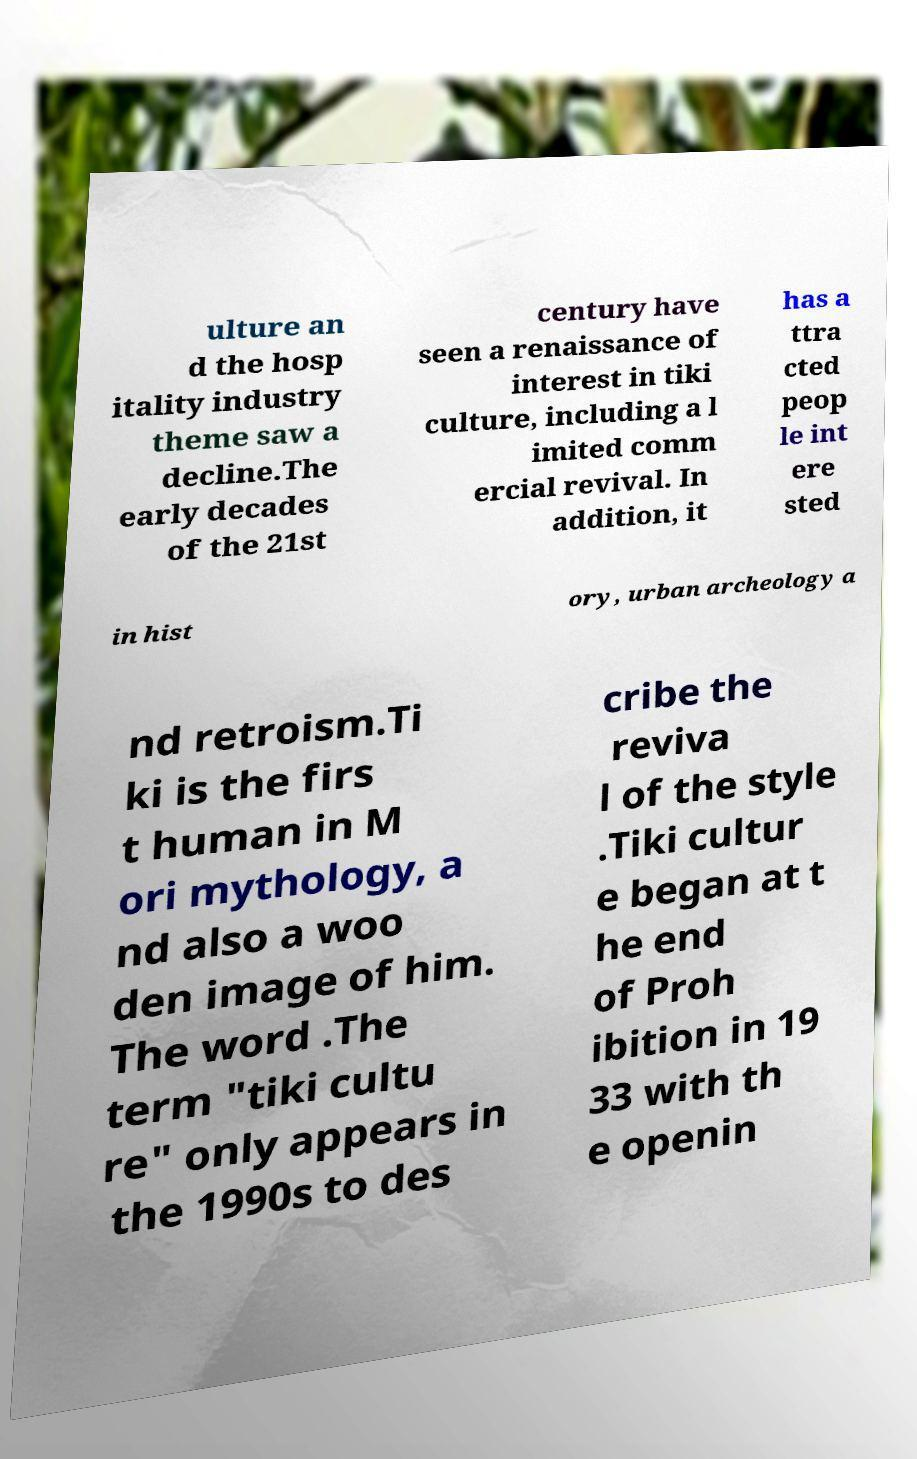Please identify and transcribe the text found in this image. ulture an d the hosp itality industry theme saw a decline.The early decades of the 21st century have seen a renaissance of interest in tiki culture, including a l imited comm ercial revival. In addition, it has a ttra cted peop le int ere sted in hist ory, urban archeology a nd retroism.Ti ki is the firs t human in M ori mythology, a nd also a woo den image of him. The word .The term "tiki cultu re" only appears in the 1990s to des cribe the reviva l of the style .Tiki cultur e began at t he end of Proh ibition in 19 33 with th e openin 